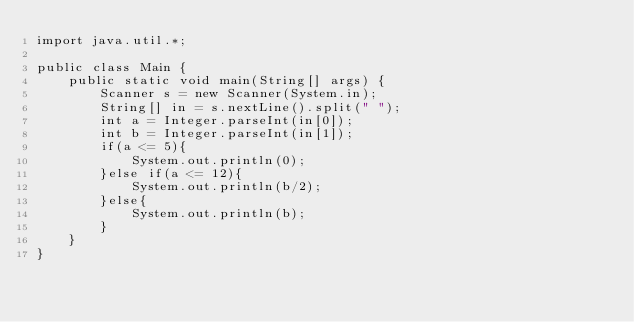Convert code to text. <code><loc_0><loc_0><loc_500><loc_500><_Java_>import java.util.*;

public class Main {
    public static void main(String[] args) {
        Scanner s = new Scanner(System.in);
        String[] in = s.nextLine().split(" ");
        int a = Integer.parseInt(in[0]);
        int b = Integer.parseInt(in[1]);
        if(a <= 5){
            System.out.println(0);
        }else if(a <= 12){
            System.out.println(b/2);
        }else{
            System.out.println(b);
        }
    }
}</code> 